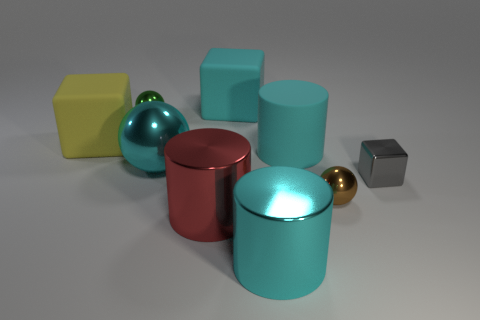How many cyan cylinders must be subtracted to get 1 cyan cylinders? 1 Subtract all big yellow cubes. How many cubes are left? 2 Add 1 small blocks. How many objects exist? 10 Subtract all blocks. How many objects are left? 6 Subtract all gray cubes. How many cubes are left? 2 Subtract 0 blue cubes. How many objects are left? 9 Subtract 1 cylinders. How many cylinders are left? 2 Subtract all red spheres. Subtract all brown cubes. How many spheres are left? 3 Subtract all blue balls. How many yellow cubes are left? 1 Subtract all red metal objects. Subtract all tiny shiny blocks. How many objects are left? 7 